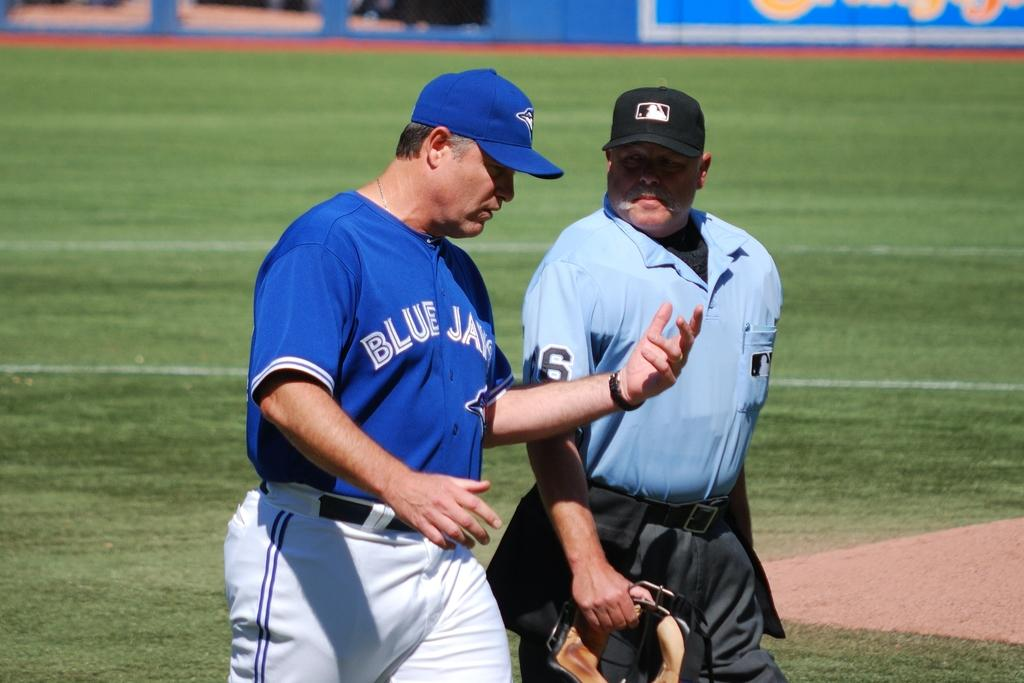<image>
Offer a succinct explanation of the picture presented. A person wearing a Blue Jays shirt talking to an umpire. 